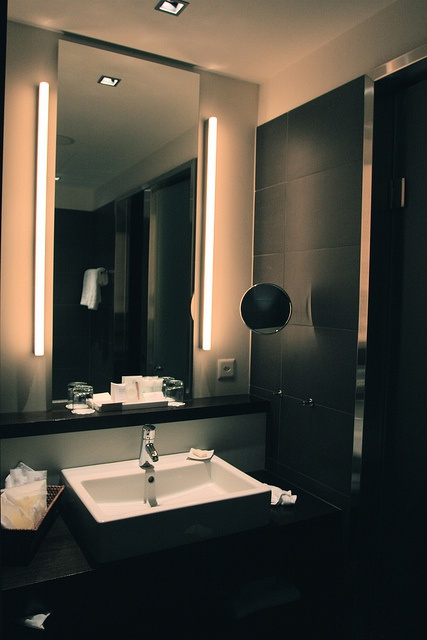Describe the objects in this image and their specific colors. I can see a sink in black and tan tones in this image. 